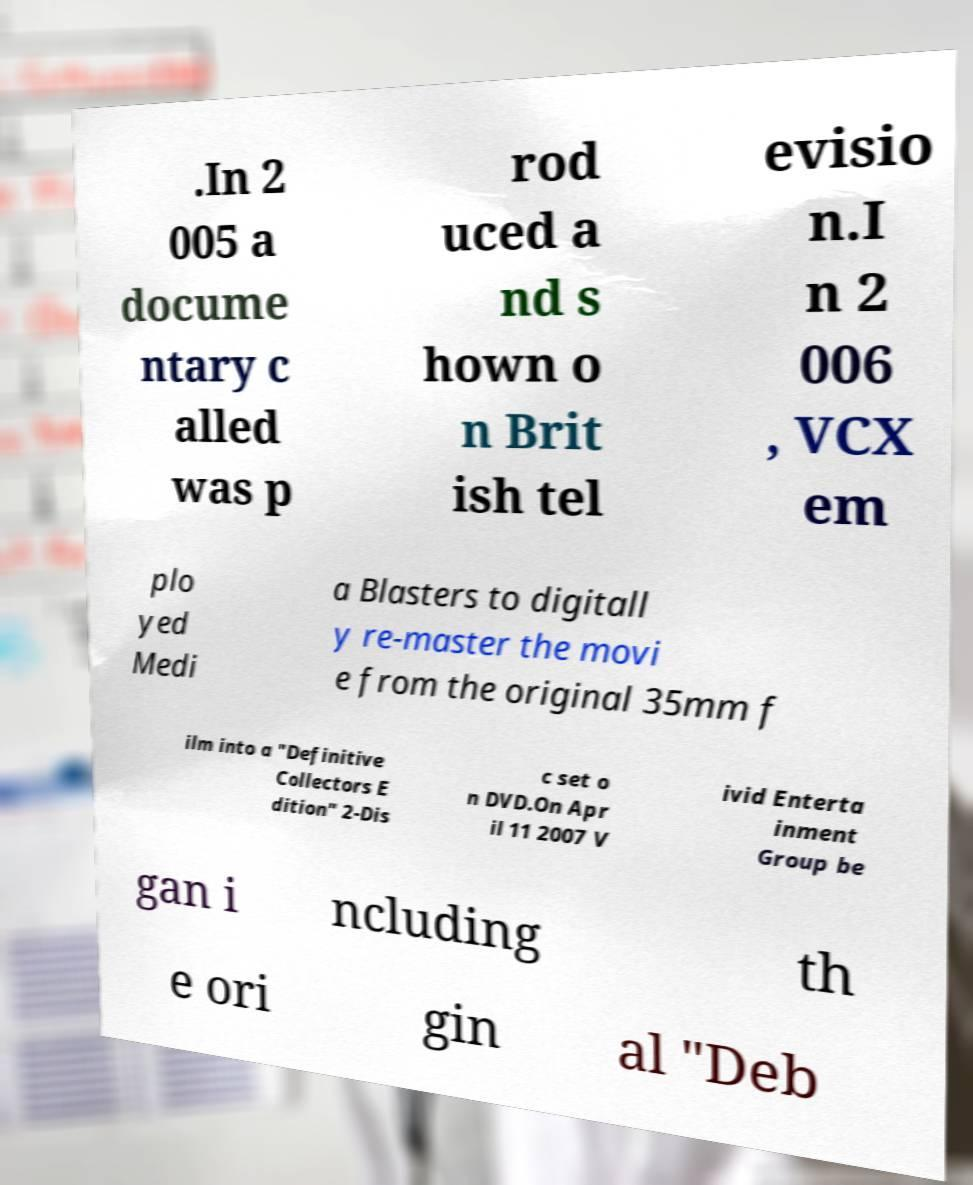Can you accurately transcribe the text from the provided image for me? .In 2 005 a docume ntary c alled was p rod uced a nd s hown o n Brit ish tel evisio n.I n 2 006 , VCX em plo yed Medi a Blasters to digitall y re-master the movi e from the original 35mm f ilm into a "Definitive Collectors E dition" 2-Dis c set o n DVD.On Apr il 11 2007 V ivid Enterta inment Group be gan i ncluding th e ori gin al "Deb 